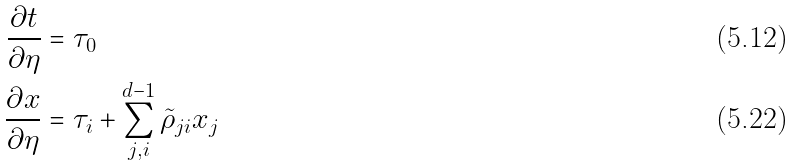Convert formula to latex. <formula><loc_0><loc_0><loc_500><loc_500>\frac { \partial t } { \partial \eta } & = \tau _ { 0 } \\ \frac { \partial x } { \partial \eta } & = \tau _ { i } + \sum _ { j , i } ^ { d - 1 } \tilde { \rho } _ { j i } x _ { j }</formula> 